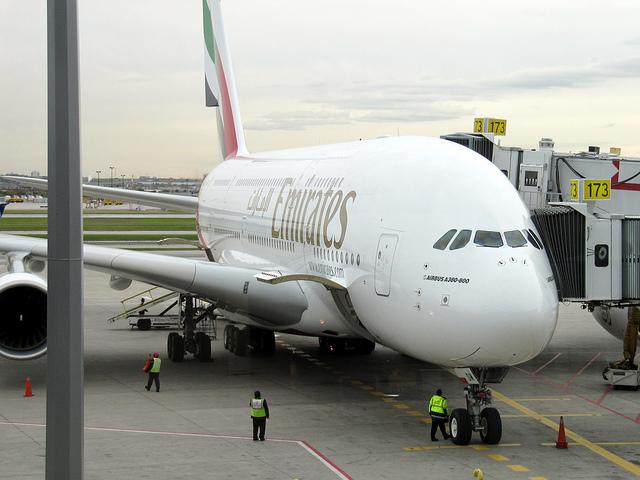How many workers are visible?
Answer briefly. 3. What airline is this plane?
Quick response, please. Emirates. What gate number is shown?
Quick response, please. 173. 